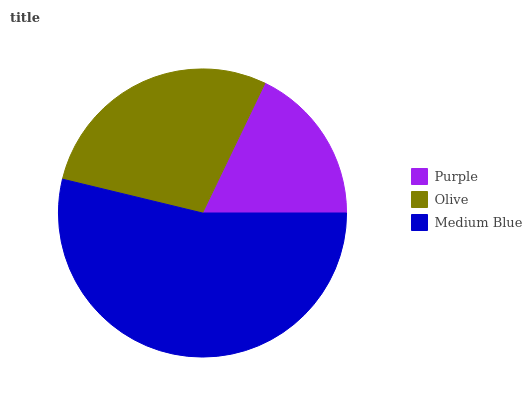Is Purple the minimum?
Answer yes or no. Yes. Is Medium Blue the maximum?
Answer yes or no. Yes. Is Olive the minimum?
Answer yes or no. No. Is Olive the maximum?
Answer yes or no. No. Is Olive greater than Purple?
Answer yes or no. Yes. Is Purple less than Olive?
Answer yes or no. Yes. Is Purple greater than Olive?
Answer yes or no. No. Is Olive less than Purple?
Answer yes or no. No. Is Olive the high median?
Answer yes or no. Yes. Is Olive the low median?
Answer yes or no. Yes. Is Medium Blue the high median?
Answer yes or no. No. Is Purple the low median?
Answer yes or no. No. 